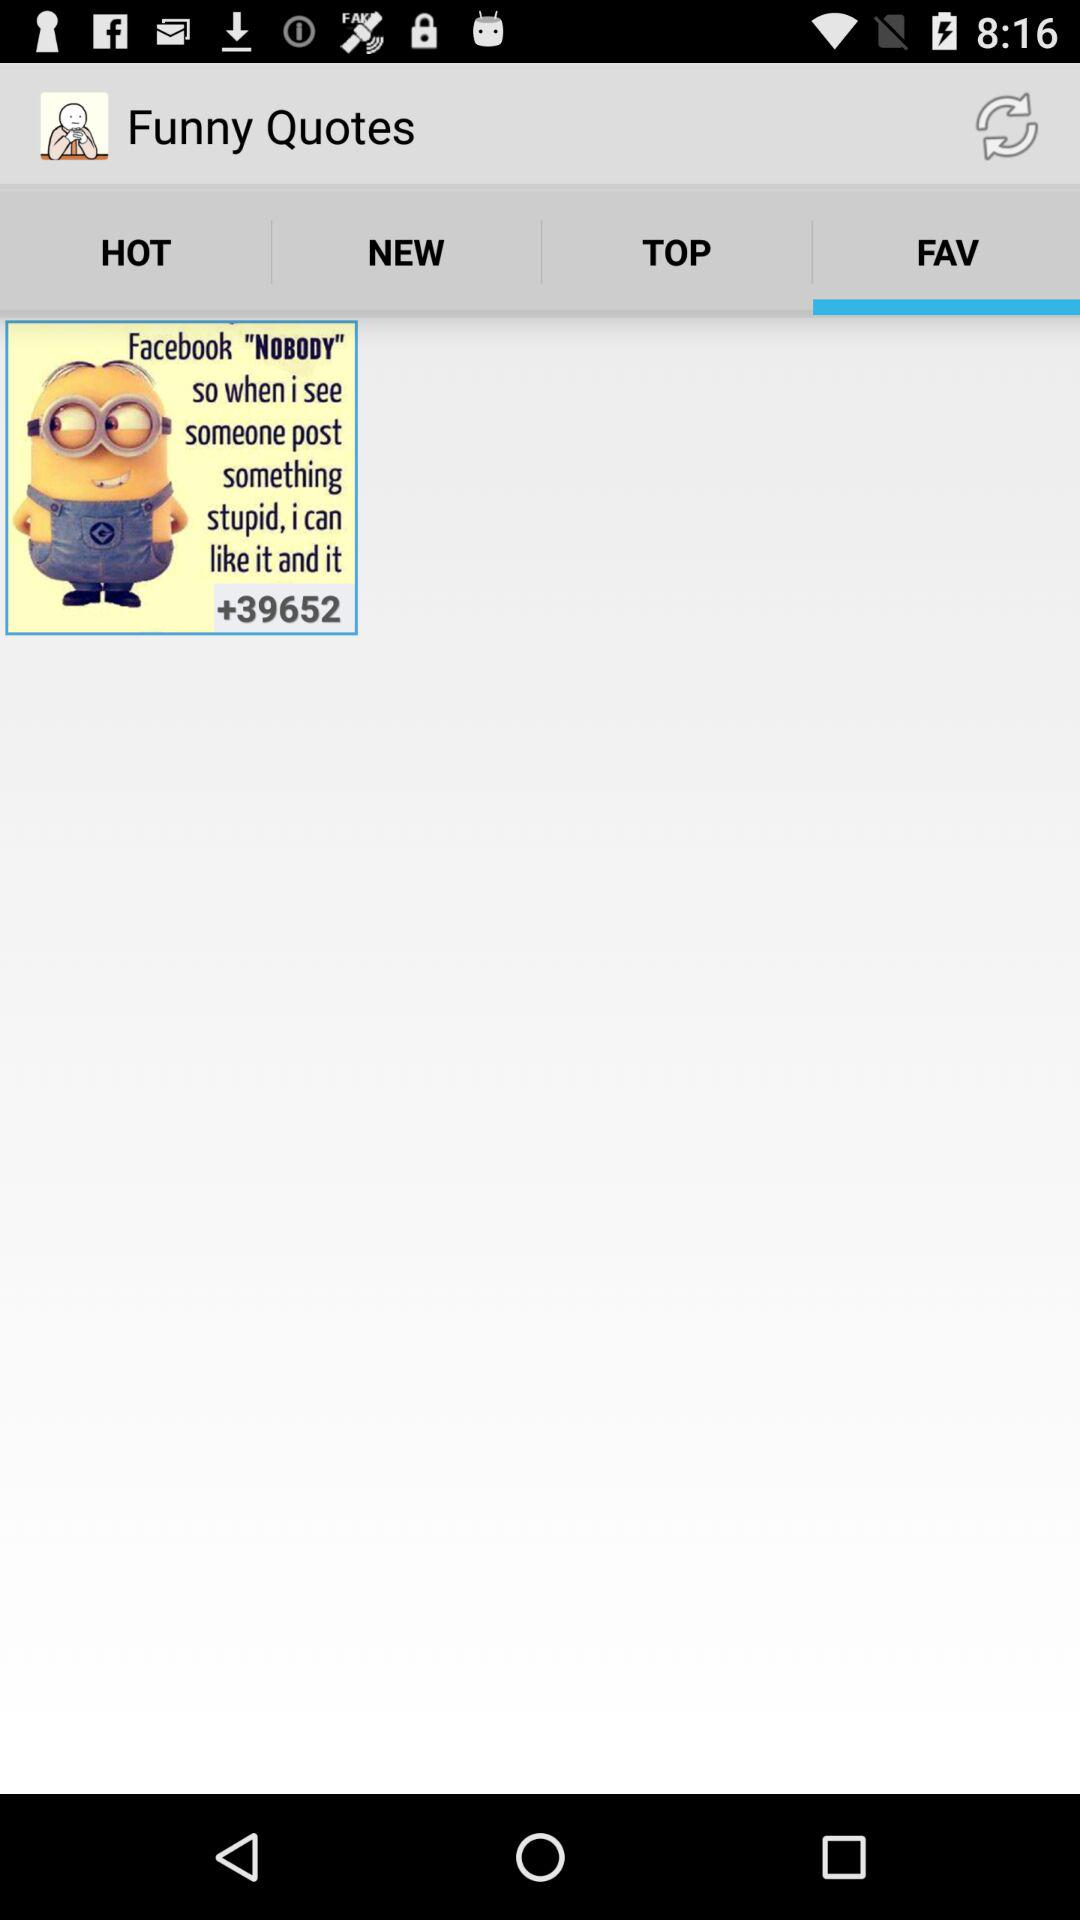Which option is selected in "Funny Quotes"? The selected option in "Funny Quotes" is "FAV". 